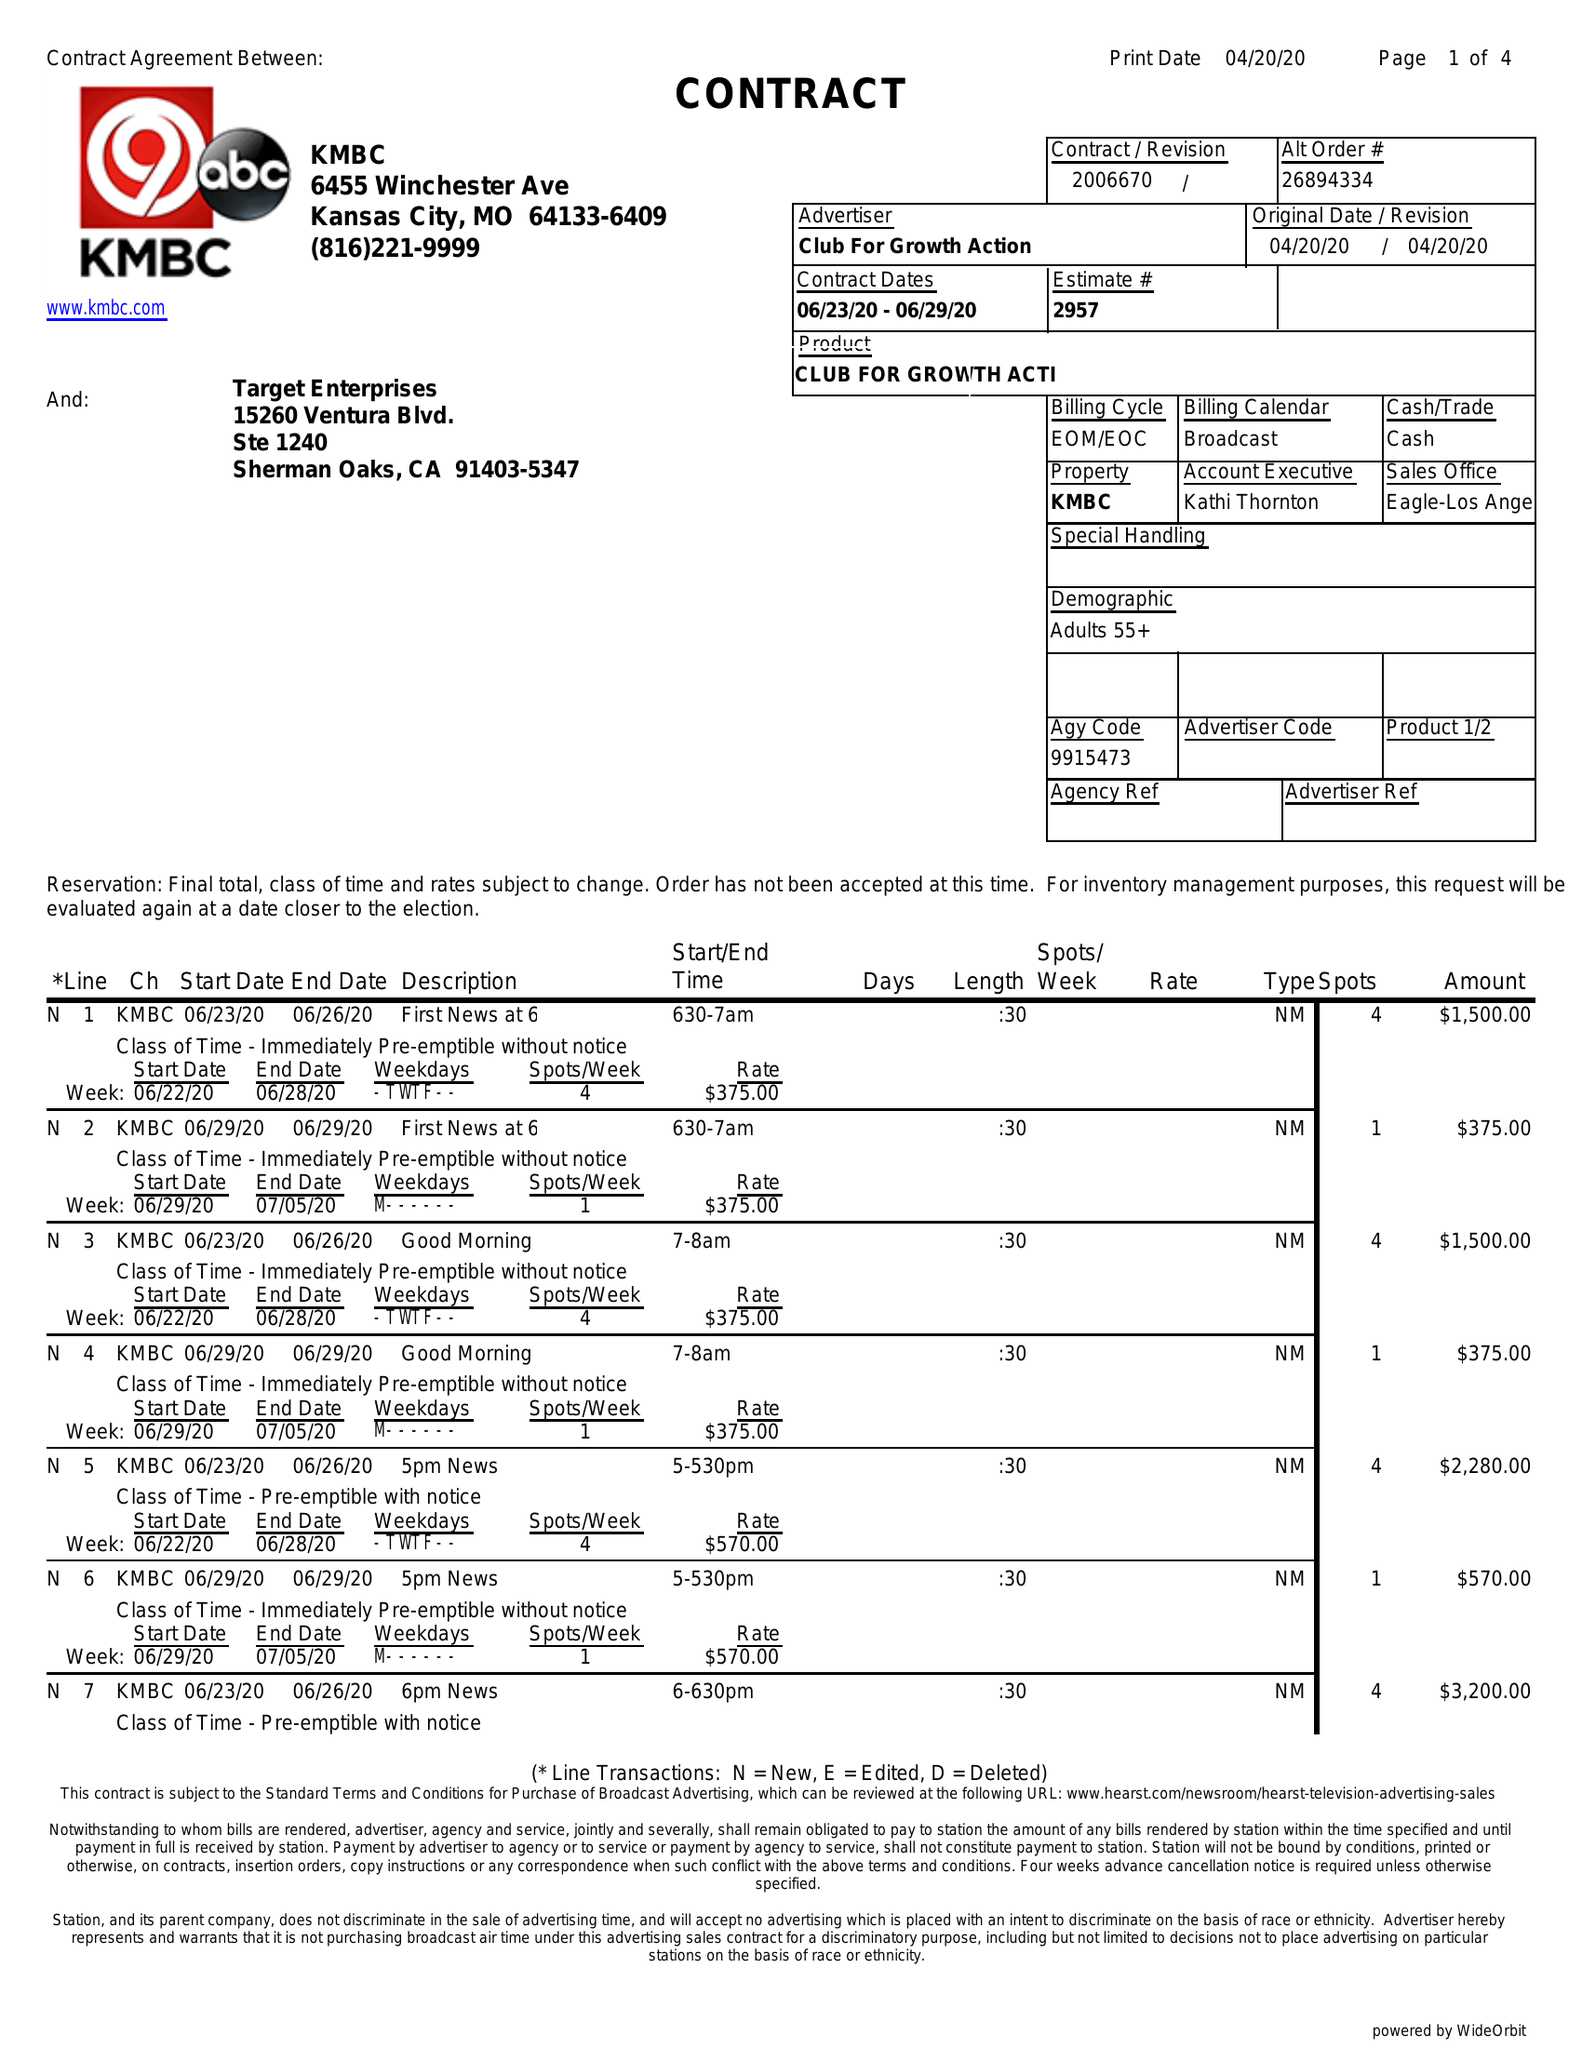What is the value for the gross_amount?
Answer the question using a single word or phrase. 12100.00 